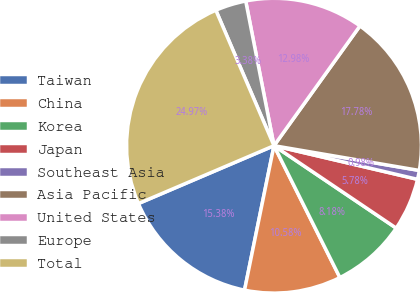Convert chart. <chart><loc_0><loc_0><loc_500><loc_500><pie_chart><fcel>Taiwan<fcel>China<fcel>Korea<fcel>Japan<fcel>Southeast Asia<fcel>Asia Pacific<fcel>United States<fcel>Europe<fcel>Total<nl><fcel>15.38%<fcel>10.58%<fcel>8.18%<fcel>5.78%<fcel>0.98%<fcel>17.78%<fcel>12.98%<fcel>3.38%<fcel>24.97%<nl></chart> 